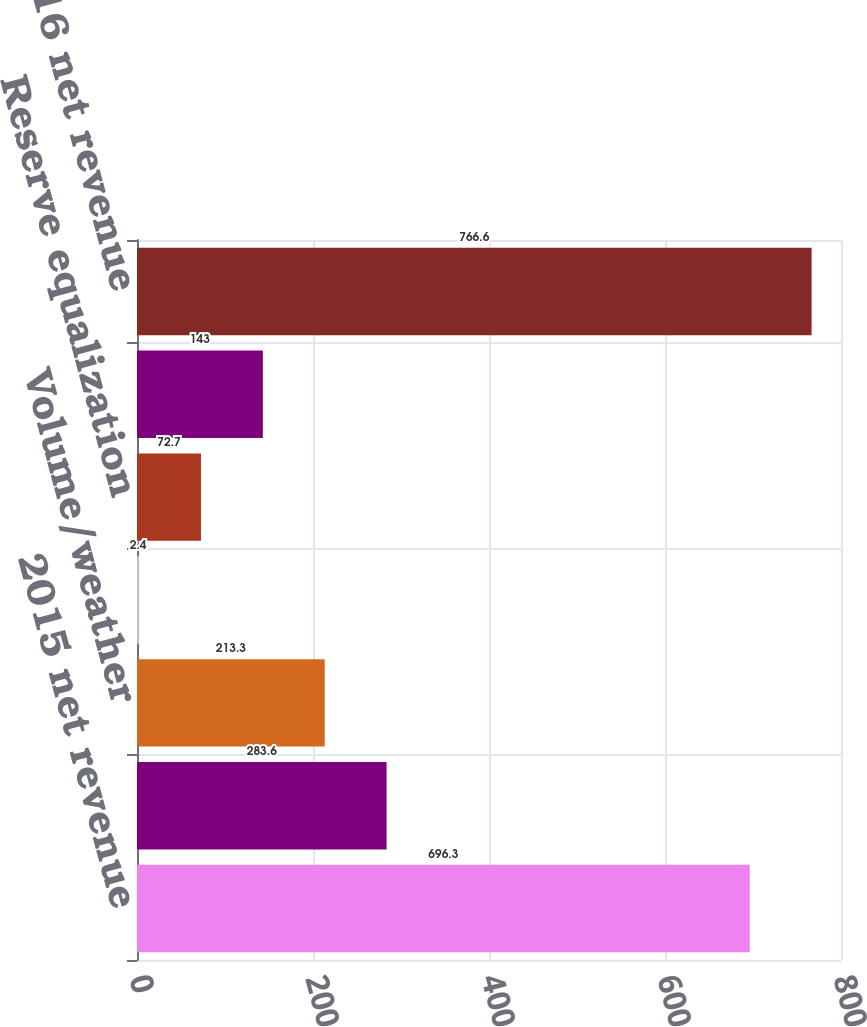Convert chart. <chart><loc_0><loc_0><loc_500><loc_500><bar_chart><fcel>2015 net revenue<fcel>Retail electric price<fcel>Volume/weather<fcel>Net wholesale revenue<fcel>Reserve equalization<fcel>Other<fcel>2016 net revenue<nl><fcel>696.3<fcel>283.6<fcel>213.3<fcel>2.4<fcel>72.7<fcel>143<fcel>766.6<nl></chart> 